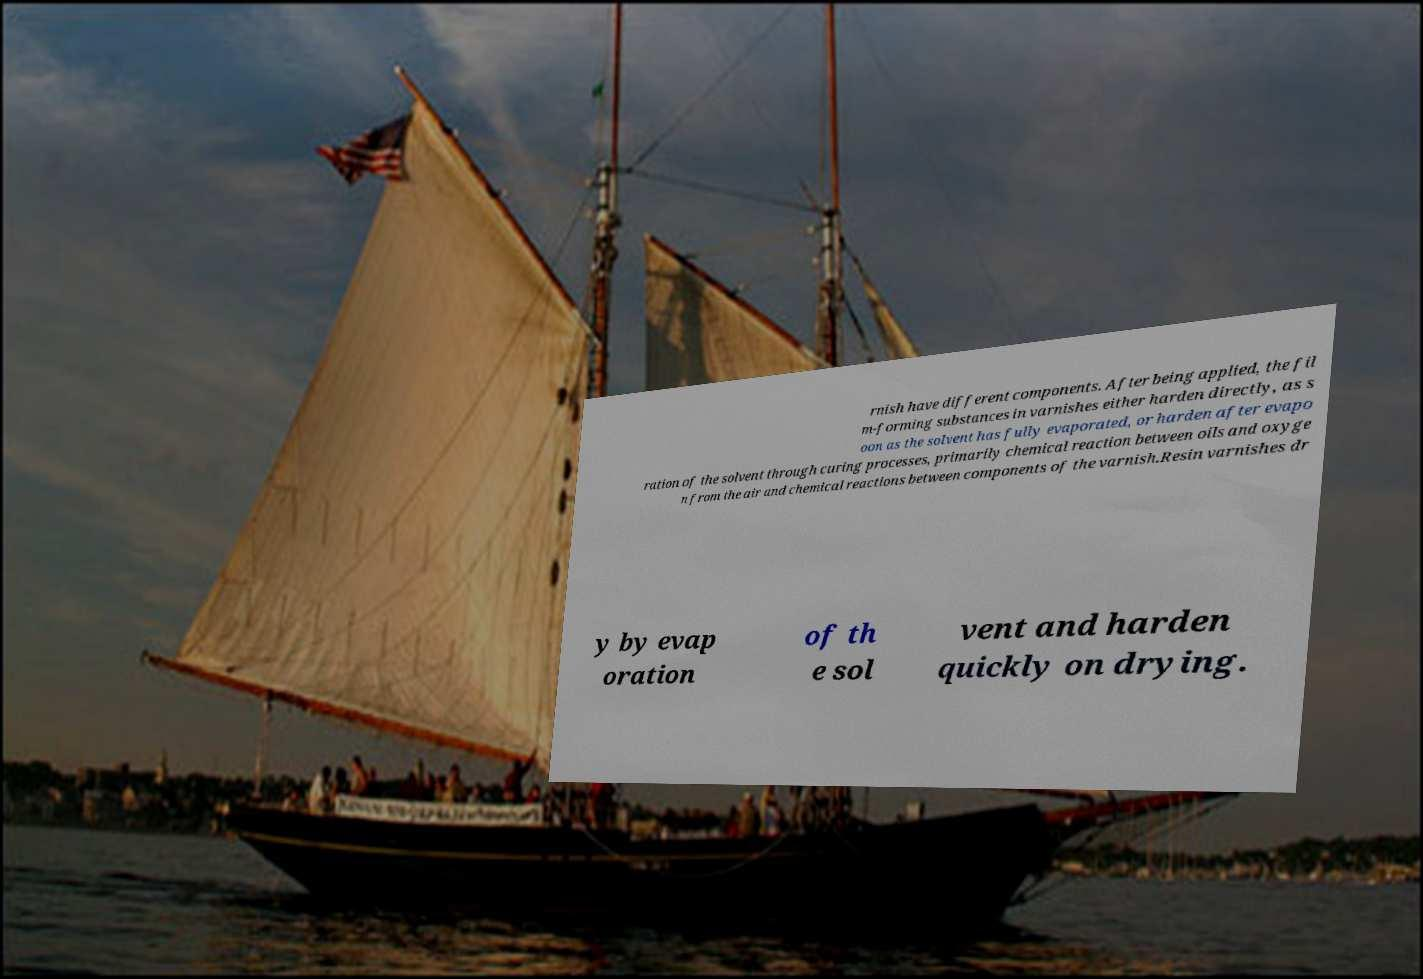Please read and relay the text visible in this image. What does it say? rnish have different components. After being applied, the fil m-forming substances in varnishes either harden directly, as s oon as the solvent has fully evaporated, or harden after evapo ration of the solvent through curing processes, primarily chemical reaction between oils and oxyge n from the air and chemical reactions between components of the varnish.Resin varnishes dr y by evap oration of th e sol vent and harden quickly on drying. 